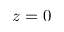<formula> <loc_0><loc_0><loc_500><loc_500>z = 0</formula> 